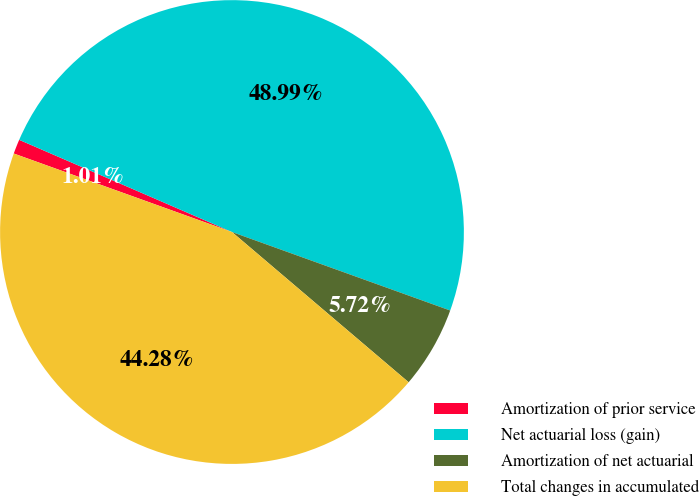<chart> <loc_0><loc_0><loc_500><loc_500><pie_chart><fcel>Amortization of prior service<fcel>Net actuarial loss (gain)<fcel>Amortization of net actuarial<fcel>Total changes in accumulated<nl><fcel>1.01%<fcel>48.99%<fcel>5.72%<fcel>44.28%<nl></chart> 